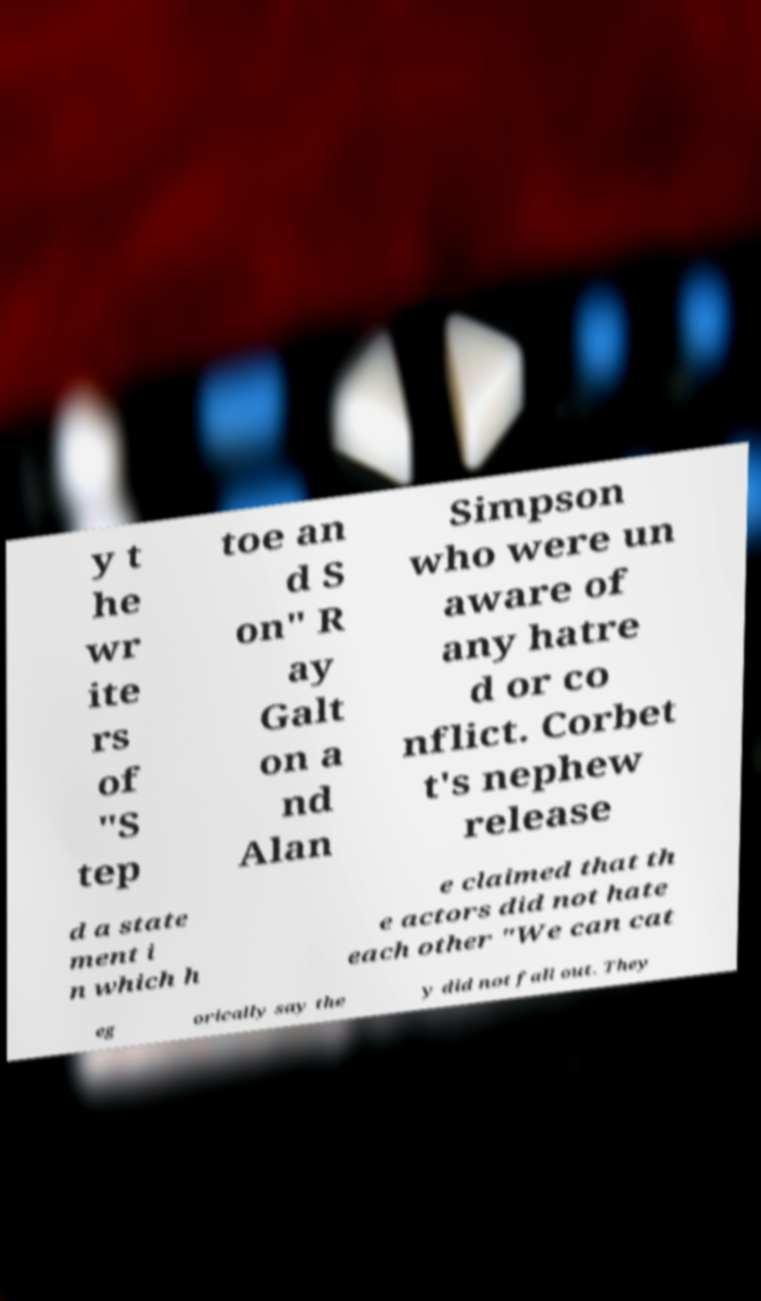I need the written content from this picture converted into text. Can you do that? y t he wr ite rs of "S tep toe an d S on" R ay Galt on a nd Alan Simpson who were un aware of any hatre d or co nflict. Corbet t's nephew release d a state ment i n which h e claimed that th e actors did not hate each other "We can cat eg orically say the y did not fall out. They 